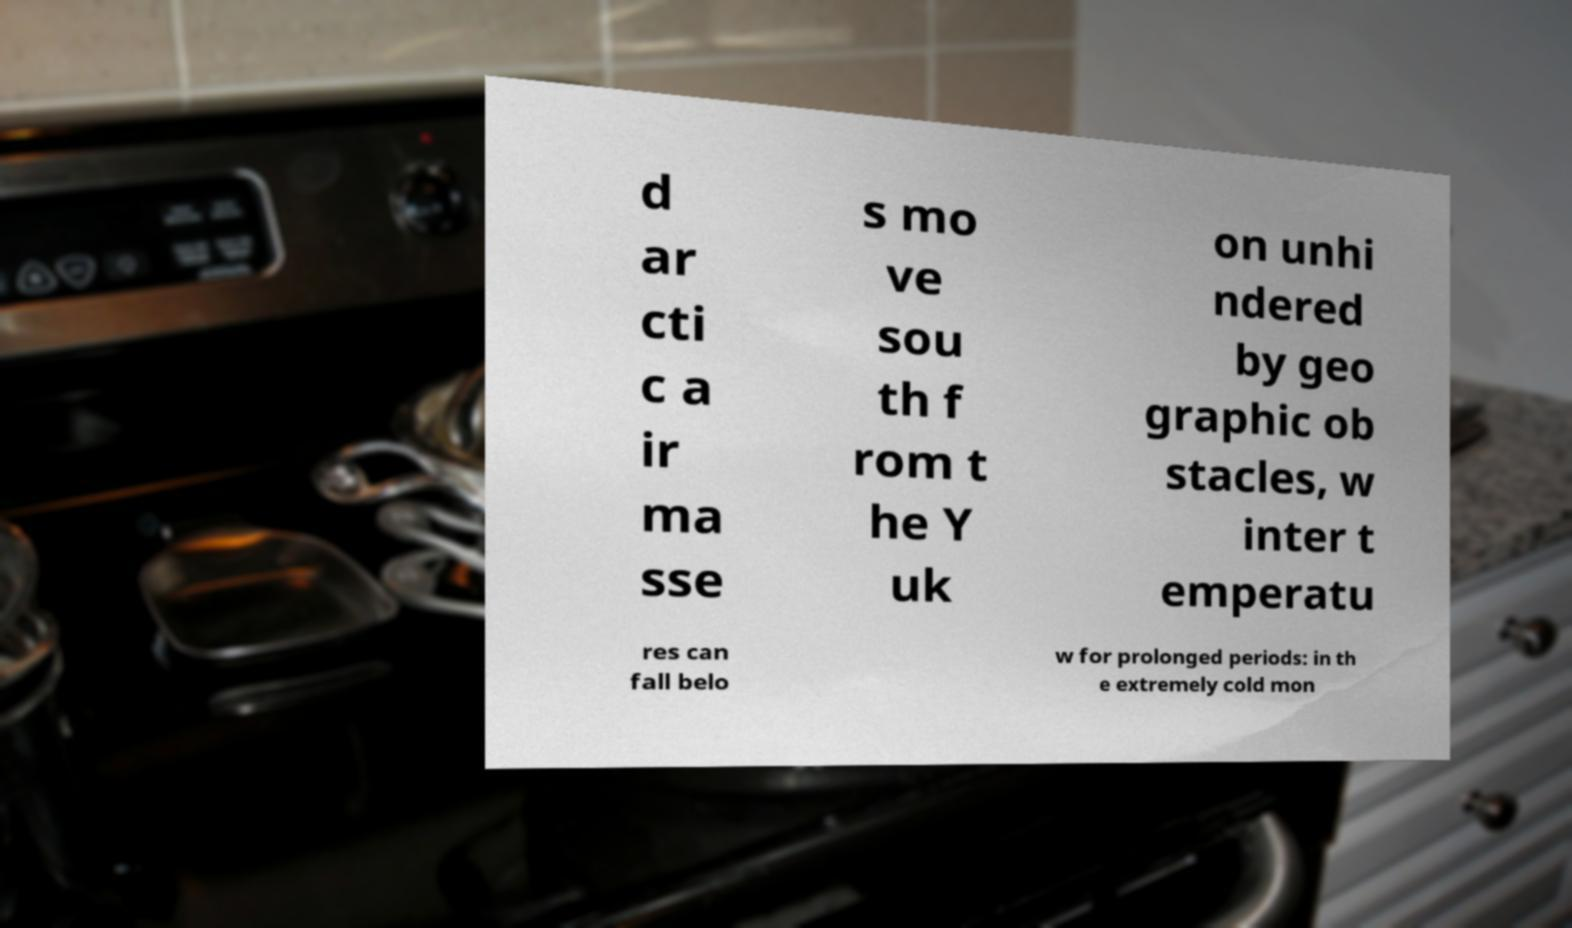What messages or text are displayed in this image? I need them in a readable, typed format. d ar cti c a ir ma sse s mo ve sou th f rom t he Y uk on unhi ndered by geo graphic ob stacles, w inter t emperatu res can fall belo w for prolonged periods: in th e extremely cold mon 